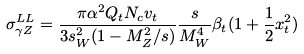Convert formula to latex. <formula><loc_0><loc_0><loc_500><loc_500>\sigma _ { \gamma Z } ^ { L L } = \frac { \pi \alpha ^ { 2 } Q _ { t } N _ { c } v _ { t } } { 3 s _ { W } ^ { 2 } ( 1 - M _ { Z } ^ { 2 } / s ) } \frac { s } { M _ { W } ^ { 4 } } \beta _ { t } ( 1 + \frac { 1 } { 2 } x _ { t } ^ { 2 } )</formula> 